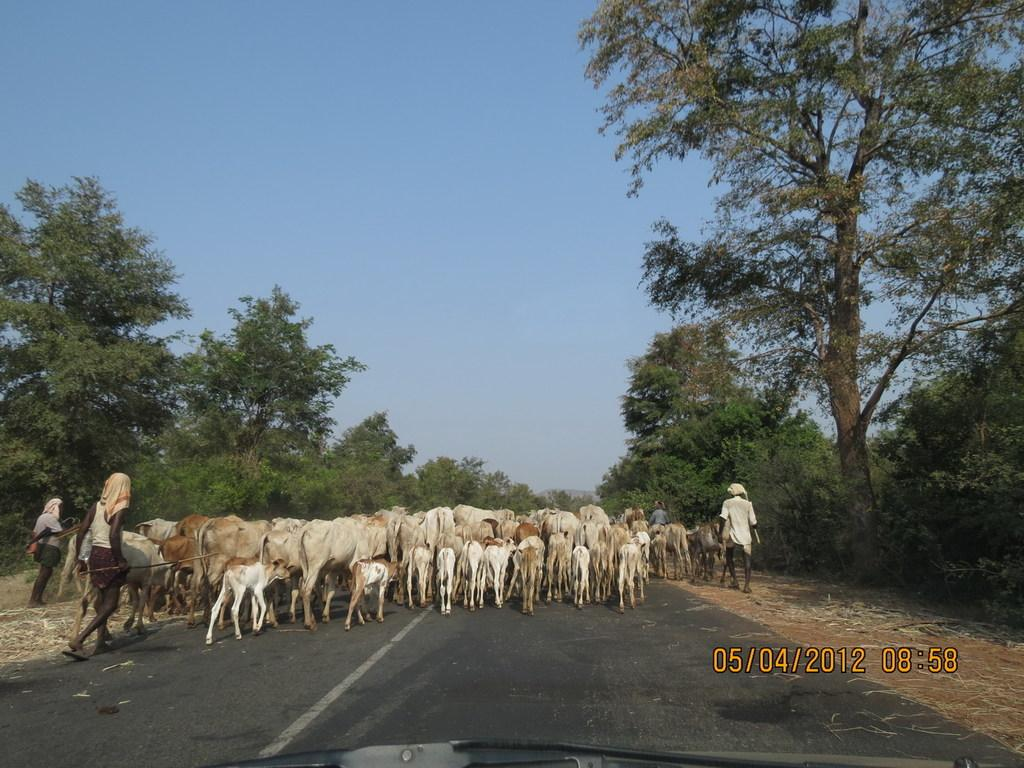What animals can be seen in the image? There is a group of cows in the image. What are the people in the image doing? The people in the image are walking on the road. What objects are some people holding in the image? Some people are holding sticks in the image. What can be seen in the distance in the image? The sky is visible in the background of the image. What type of story is being told by the monkey in the image? There is no monkey present in the image, so no story is being told by a monkey. 